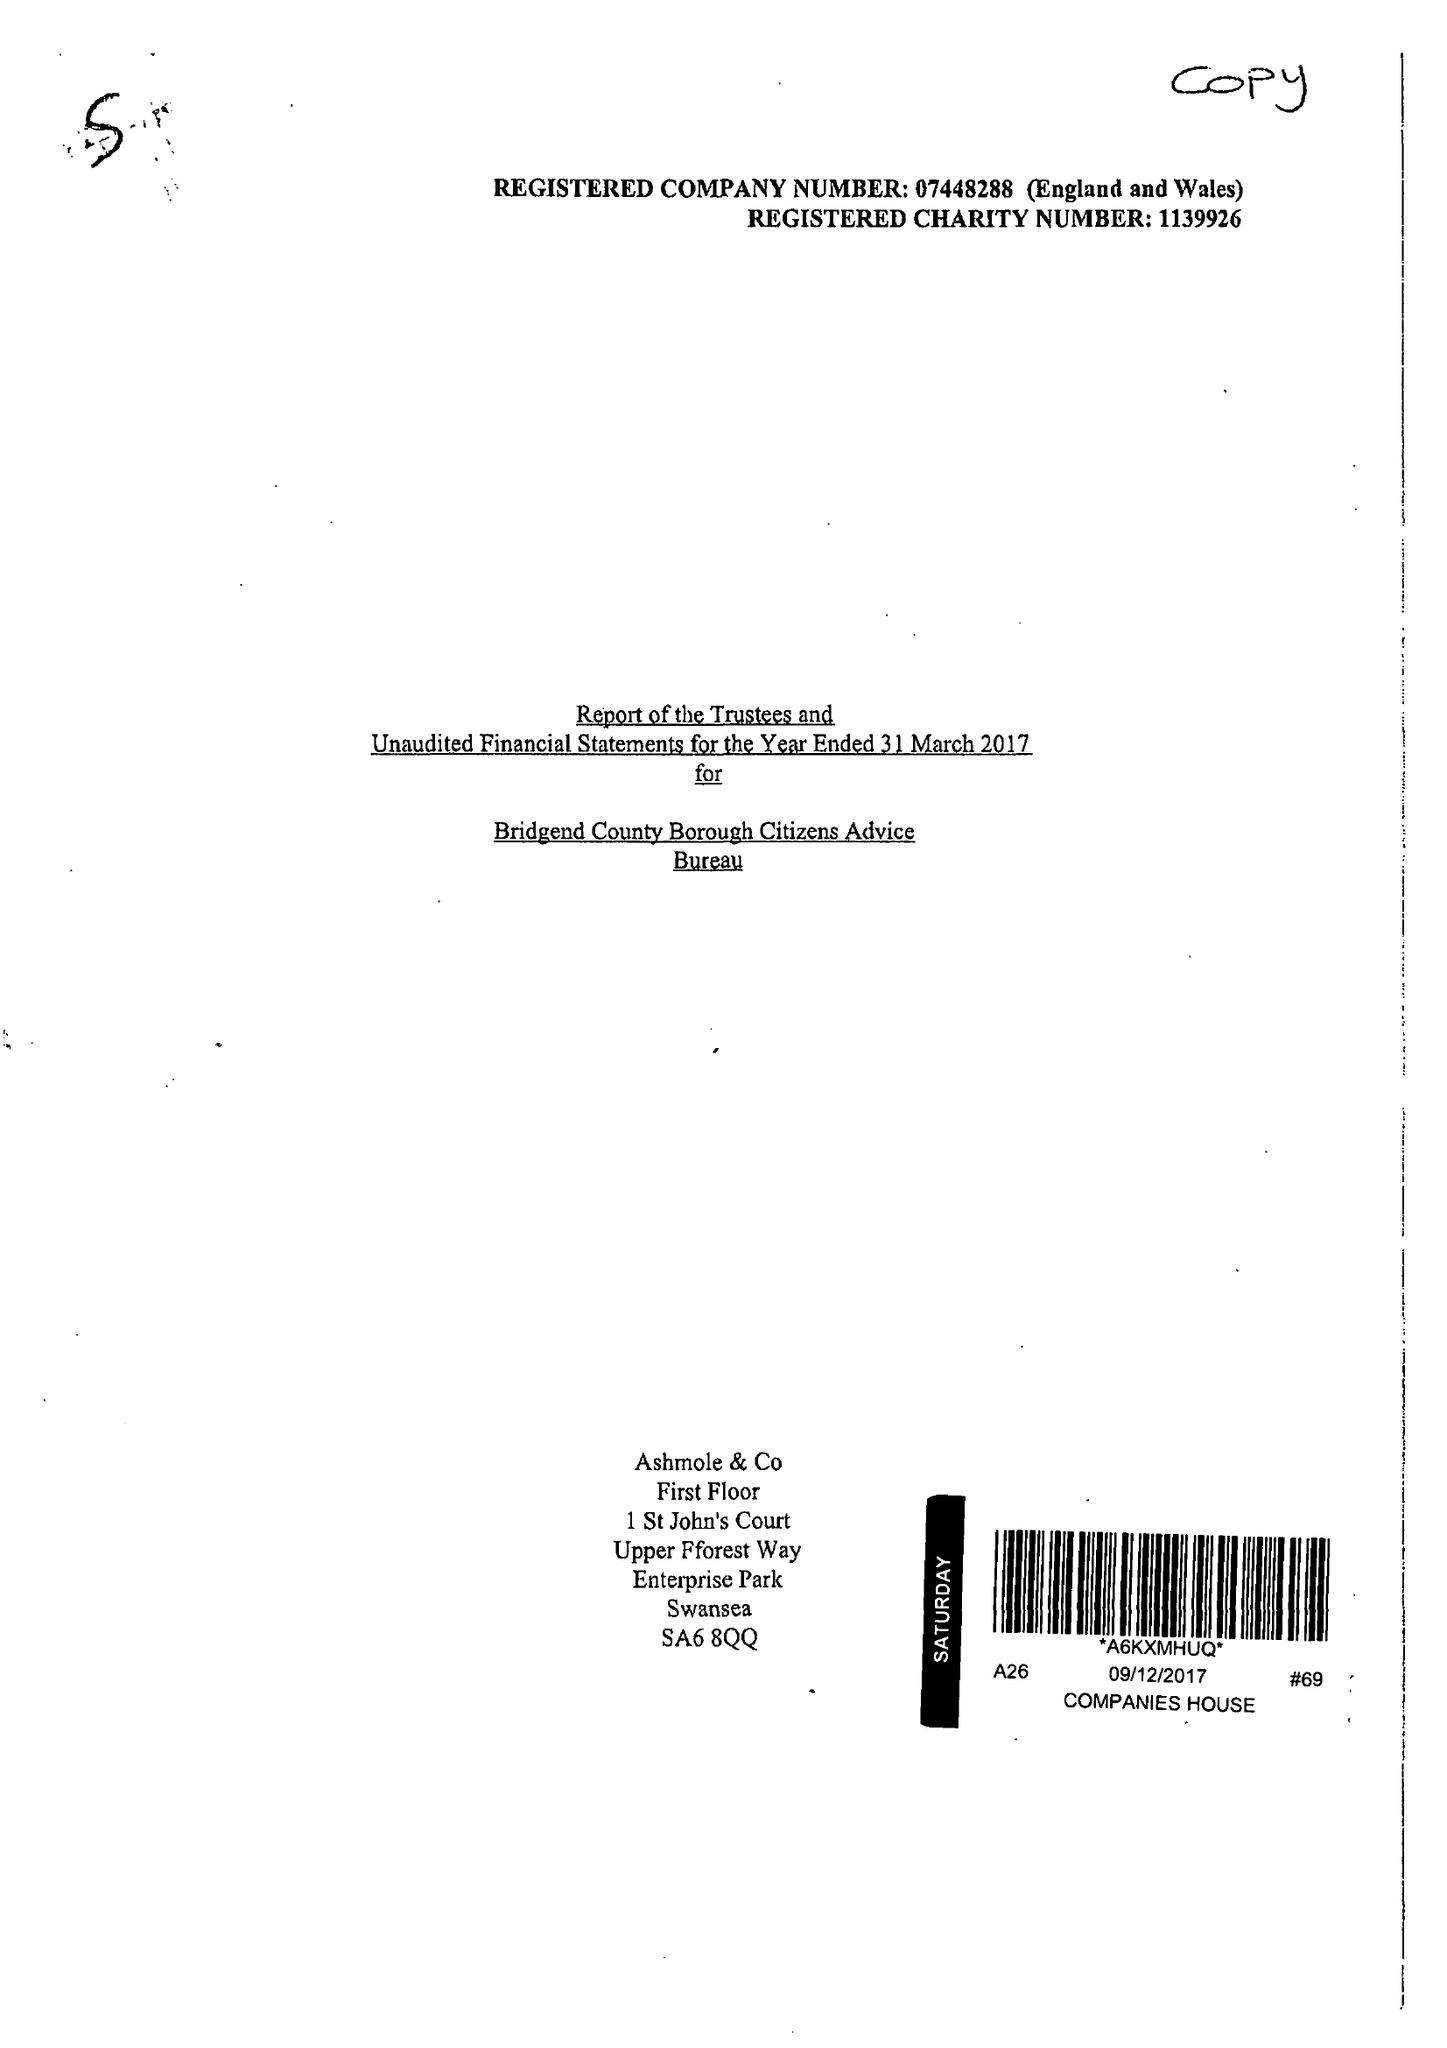What is the value for the income_annually_in_british_pounds?
Answer the question using a single word or phrase. 445696.00 